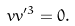<formula> <loc_0><loc_0><loc_500><loc_500>v v ^ { \prime 3 } = 0 .</formula> 